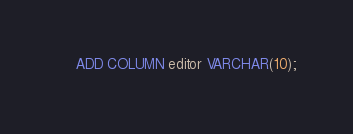Convert code to text. <code><loc_0><loc_0><loc_500><loc_500><_SQL_>    ADD COLUMN editor VARCHAR(10);
</code> 